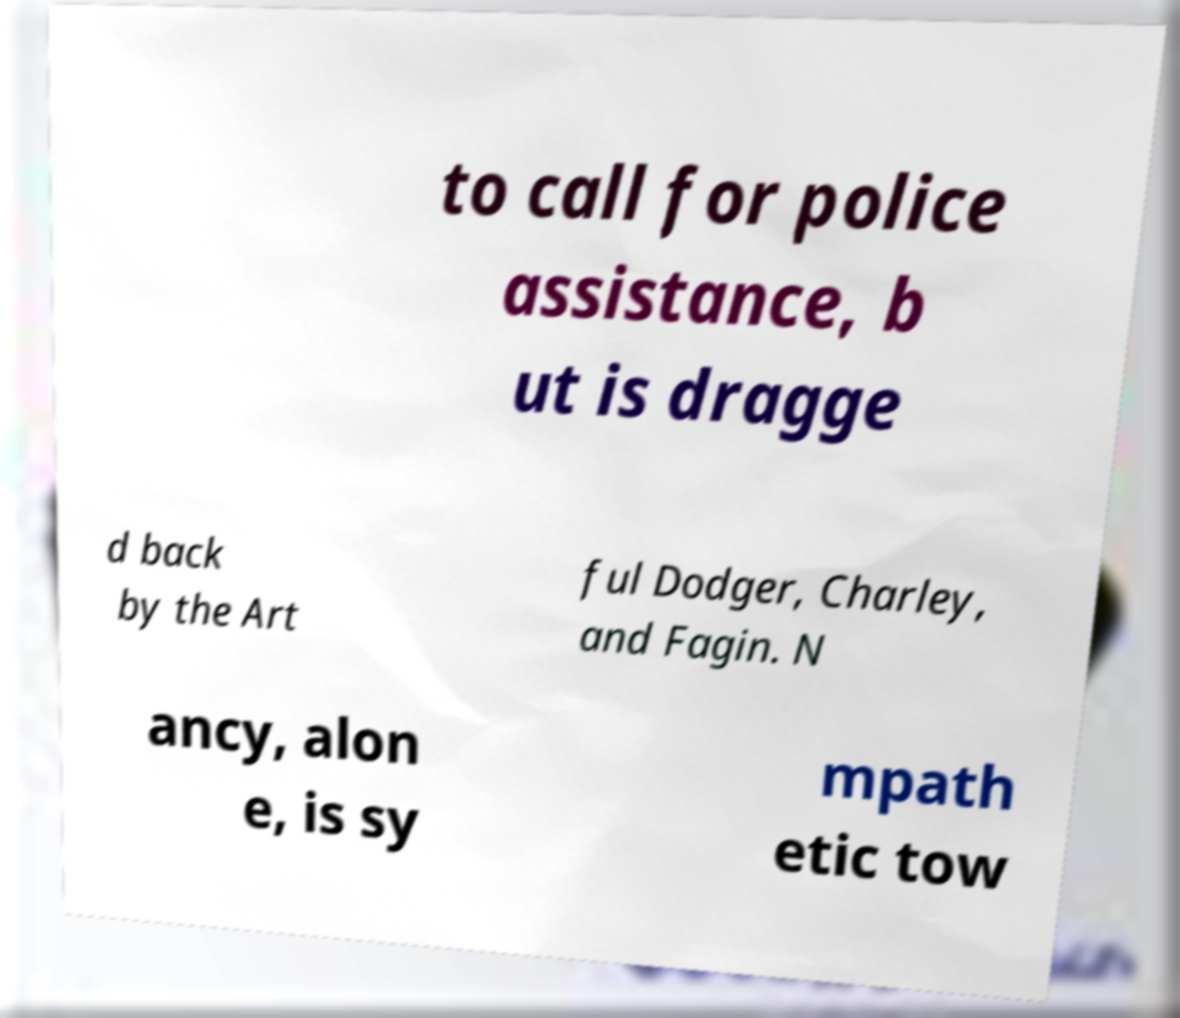I need the written content from this picture converted into text. Can you do that? to call for police assistance, b ut is dragge d back by the Art ful Dodger, Charley, and Fagin. N ancy, alon e, is sy mpath etic tow 